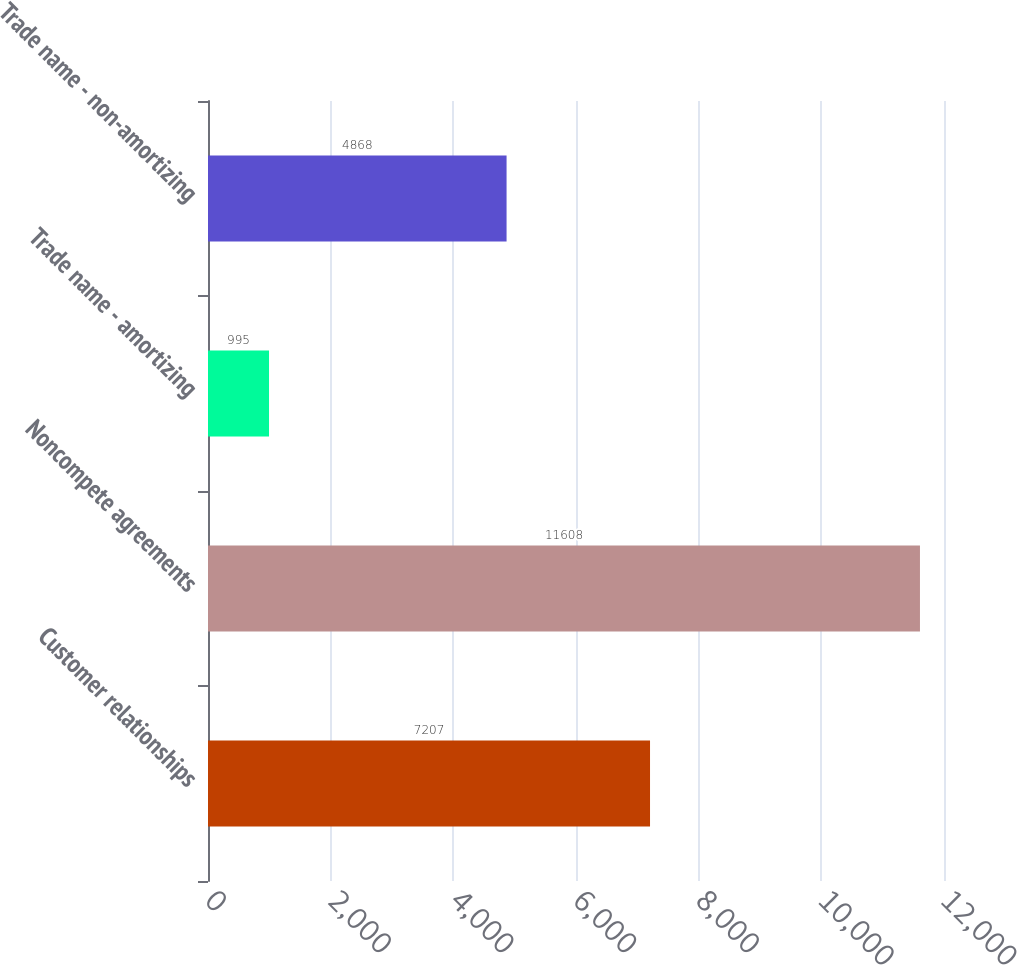<chart> <loc_0><loc_0><loc_500><loc_500><bar_chart><fcel>Customer relationships<fcel>Noncompete agreements<fcel>Trade name - amortizing<fcel>Trade name - non-amortizing<nl><fcel>7207<fcel>11608<fcel>995<fcel>4868<nl></chart> 